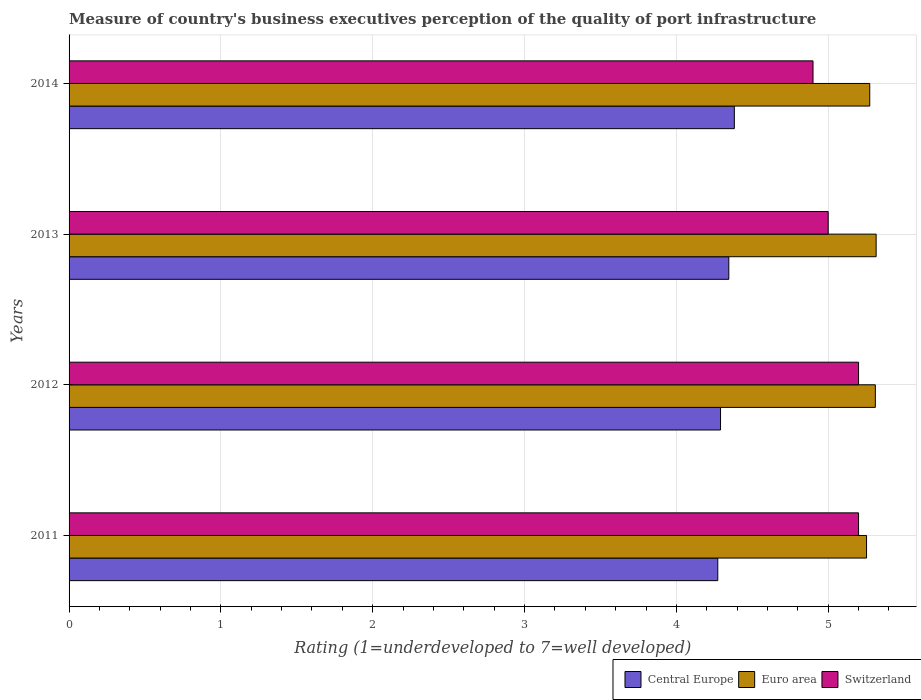Are the number of bars on each tick of the Y-axis equal?
Ensure brevity in your answer.  Yes. How many bars are there on the 4th tick from the top?
Your answer should be compact. 3. What is the label of the 3rd group of bars from the top?
Provide a succinct answer. 2012. What is the ratings of the quality of port infrastructure in Euro area in 2014?
Offer a terse response. 5.27. Across all years, what is the maximum ratings of the quality of port infrastructure in Euro area?
Ensure brevity in your answer.  5.32. In which year was the ratings of the quality of port infrastructure in Switzerland maximum?
Provide a succinct answer. 2011. In which year was the ratings of the quality of port infrastructure in Switzerland minimum?
Give a very brief answer. 2014. What is the total ratings of the quality of port infrastructure in Euro area in the graph?
Give a very brief answer. 21.15. What is the difference between the ratings of the quality of port infrastructure in Switzerland in 2012 and that in 2013?
Give a very brief answer. 0.2. What is the difference between the ratings of the quality of port infrastructure in Switzerland in 2011 and the ratings of the quality of port infrastructure in Central Europe in 2013?
Ensure brevity in your answer.  0.85. What is the average ratings of the quality of port infrastructure in Switzerland per year?
Provide a succinct answer. 5.08. In the year 2013, what is the difference between the ratings of the quality of port infrastructure in Switzerland and ratings of the quality of port infrastructure in Central Europe?
Make the answer very short. 0.65. In how many years, is the ratings of the quality of port infrastructure in Central Europe greater than 4.4 ?
Your answer should be very brief. 0. What is the ratio of the ratings of the quality of port infrastructure in Switzerland in 2011 to that in 2014?
Your answer should be compact. 1.06. Is the ratings of the quality of port infrastructure in Central Europe in 2011 less than that in 2012?
Provide a succinct answer. Yes. Is the difference between the ratings of the quality of port infrastructure in Switzerland in 2012 and 2013 greater than the difference between the ratings of the quality of port infrastructure in Central Europe in 2012 and 2013?
Keep it short and to the point. Yes. What is the difference between the highest and the second highest ratings of the quality of port infrastructure in Central Europe?
Ensure brevity in your answer.  0.04. What is the difference between the highest and the lowest ratings of the quality of port infrastructure in Switzerland?
Provide a short and direct response. 0.3. In how many years, is the ratings of the quality of port infrastructure in Central Europe greater than the average ratings of the quality of port infrastructure in Central Europe taken over all years?
Your answer should be very brief. 2. What does the 3rd bar from the top in 2012 represents?
Give a very brief answer. Central Europe. What does the 1st bar from the bottom in 2011 represents?
Your answer should be very brief. Central Europe. How many bars are there?
Make the answer very short. 12. Are all the bars in the graph horizontal?
Give a very brief answer. Yes. What is the difference between two consecutive major ticks on the X-axis?
Offer a very short reply. 1. Where does the legend appear in the graph?
Provide a succinct answer. Bottom right. How many legend labels are there?
Your response must be concise. 3. How are the legend labels stacked?
Ensure brevity in your answer.  Horizontal. What is the title of the graph?
Give a very brief answer. Measure of country's business executives perception of the quality of port infrastructure. Does "Georgia" appear as one of the legend labels in the graph?
Your answer should be compact. No. What is the label or title of the X-axis?
Ensure brevity in your answer.  Rating (1=underdeveloped to 7=well developed). What is the label or title of the Y-axis?
Make the answer very short. Years. What is the Rating (1=underdeveloped to 7=well developed) in Central Europe in 2011?
Provide a short and direct response. 4.27. What is the Rating (1=underdeveloped to 7=well developed) in Euro area in 2011?
Offer a very short reply. 5.25. What is the Rating (1=underdeveloped to 7=well developed) of Switzerland in 2011?
Give a very brief answer. 5.2. What is the Rating (1=underdeveloped to 7=well developed) of Central Europe in 2012?
Your answer should be very brief. 4.29. What is the Rating (1=underdeveloped to 7=well developed) in Euro area in 2012?
Give a very brief answer. 5.31. What is the Rating (1=underdeveloped to 7=well developed) in Central Europe in 2013?
Give a very brief answer. 4.35. What is the Rating (1=underdeveloped to 7=well developed) of Euro area in 2013?
Your answer should be very brief. 5.32. What is the Rating (1=underdeveloped to 7=well developed) in Switzerland in 2013?
Ensure brevity in your answer.  5. What is the Rating (1=underdeveloped to 7=well developed) in Central Europe in 2014?
Provide a short and direct response. 4.38. What is the Rating (1=underdeveloped to 7=well developed) of Euro area in 2014?
Provide a succinct answer. 5.27. What is the Rating (1=underdeveloped to 7=well developed) in Switzerland in 2014?
Ensure brevity in your answer.  4.9. Across all years, what is the maximum Rating (1=underdeveloped to 7=well developed) in Central Europe?
Make the answer very short. 4.38. Across all years, what is the maximum Rating (1=underdeveloped to 7=well developed) of Euro area?
Your response must be concise. 5.32. Across all years, what is the maximum Rating (1=underdeveloped to 7=well developed) in Switzerland?
Provide a short and direct response. 5.2. Across all years, what is the minimum Rating (1=underdeveloped to 7=well developed) in Central Europe?
Offer a terse response. 4.27. Across all years, what is the minimum Rating (1=underdeveloped to 7=well developed) in Euro area?
Give a very brief answer. 5.25. What is the total Rating (1=underdeveloped to 7=well developed) in Central Europe in the graph?
Offer a terse response. 17.29. What is the total Rating (1=underdeveloped to 7=well developed) in Euro area in the graph?
Ensure brevity in your answer.  21.15. What is the total Rating (1=underdeveloped to 7=well developed) in Switzerland in the graph?
Give a very brief answer. 20.3. What is the difference between the Rating (1=underdeveloped to 7=well developed) of Central Europe in 2011 and that in 2012?
Offer a very short reply. -0.02. What is the difference between the Rating (1=underdeveloped to 7=well developed) of Euro area in 2011 and that in 2012?
Offer a very short reply. -0.06. What is the difference between the Rating (1=underdeveloped to 7=well developed) in Switzerland in 2011 and that in 2012?
Provide a short and direct response. 0. What is the difference between the Rating (1=underdeveloped to 7=well developed) in Central Europe in 2011 and that in 2013?
Offer a terse response. -0.07. What is the difference between the Rating (1=underdeveloped to 7=well developed) of Euro area in 2011 and that in 2013?
Make the answer very short. -0.06. What is the difference between the Rating (1=underdeveloped to 7=well developed) of Switzerland in 2011 and that in 2013?
Your response must be concise. 0.2. What is the difference between the Rating (1=underdeveloped to 7=well developed) of Central Europe in 2011 and that in 2014?
Provide a succinct answer. -0.11. What is the difference between the Rating (1=underdeveloped to 7=well developed) of Euro area in 2011 and that in 2014?
Make the answer very short. -0.02. What is the difference between the Rating (1=underdeveloped to 7=well developed) of Central Europe in 2012 and that in 2013?
Make the answer very short. -0.05. What is the difference between the Rating (1=underdeveloped to 7=well developed) of Euro area in 2012 and that in 2013?
Provide a short and direct response. -0.01. What is the difference between the Rating (1=underdeveloped to 7=well developed) of Switzerland in 2012 and that in 2013?
Give a very brief answer. 0.2. What is the difference between the Rating (1=underdeveloped to 7=well developed) of Central Europe in 2012 and that in 2014?
Make the answer very short. -0.09. What is the difference between the Rating (1=underdeveloped to 7=well developed) in Euro area in 2012 and that in 2014?
Your response must be concise. 0.04. What is the difference between the Rating (1=underdeveloped to 7=well developed) in Switzerland in 2012 and that in 2014?
Make the answer very short. 0.3. What is the difference between the Rating (1=underdeveloped to 7=well developed) in Central Europe in 2013 and that in 2014?
Offer a terse response. -0.04. What is the difference between the Rating (1=underdeveloped to 7=well developed) in Euro area in 2013 and that in 2014?
Provide a succinct answer. 0.04. What is the difference between the Rating (1=underdeveloped to 7=well developed) of Switzerland in 2013 and that in 2014?
Keep it short and to the point. 0.1. What is the difference between the Rating (1=underdeveloped to 7=well developed) in Central Europe in 2011 and the Rating (1=underdeveloped to 7=well developed) in Euro area in 2012?
Your response must be concise. -1.04. What is the difference between the Rating (1=underdeveloped to 7=well developed) of Central Europe in 2011 and the Rating (1=underdeveloped to 7=well developed) of Switzerland in 2012?
Your response must be concise. -0.93. What is the difference between the Rating (1=underdeveloped to 7=well developed) of Euro area in 2011 and the Rating (1=underdeveloped to 7=well developed) of Switzerland in 2012?
Provide a short and direct response. 0.05. What is the difference between the Rating (1=underdeveloped to 7=well developed) of Central Europe in 2011 and the Rating (1=underdeveloped to 7=well developed) of Euro area in 2013?
Your answer should be very brief. -1.04. What is the difference between the Rating (1=underdeveloped to 7=well developed) in Central Europe in 2011 and the Rating (1=underdeveloped to 7=well developed) in Switzerland in 2013?
Your answer should be compact. -0.73. What is the difference between the Rating (1=underdeveloped to 7=well developed) of Euro area in 2011 and the Rating (1=underdeveloped to 7=well developed) of Switzerland in 2013?
Provide a short and direct response. 0.25. What is the difference between the Rating (1=underdeveloped to 7=well developed) of Central Europe in 2011 and the Rating (1=underdeveloped to 7=well developed) of Euro area in 2014?
Provide a short and direct response. -1. What is the difference between the Rating (1=underdeveloped to 7=well developed) in Central Europe in 2011 and the Rating (1=underdeveloped to 7=well developed) in Switzerland in 2014?
Keep it short and to the point. -0.63. What is the difference between the Rating (1=underdeveloped to 7=well developed) of Euro area in 2011 and the Rating (1=underdeveloped to 7=well developed) of Switzerland in 2014?
Provide a succinct answer. 0.35. What is the difference between the Rating (1=underdeveloped to 7=well developed) in Central Europe in 2012 and the Rating (1=underdeveloped to 7=well developed) in Euro area in 2013?
Keep it short and to the point. -1.02. What is the difference between the Rating (1=underdeveloped to 7=well developed) of Central Europe in 2012 and the Rating (1=underdeveloped to 7=well developed) of Switzerland in 2013?
Your response must be concise. -0.71. What is the difference between the Rating (1=underdeveloped to 7=well developed) in Euro area in 2012 and the Rating (1=underdeveloped to 7=well developed) in Switzerland in 2013?
Your answer should be compact. 0.31. What is the difference between the Rating (1=underdeveloped to 7=well developed) of Central Europe in 2012 and the Rating (1=underdeveloped to 7=well developed) of Euro area in 2014?
Your answer should be compact. -0.98. What is the difference between the Rating (1=underdeveloped to 7=well developed) in Central Europe in 2012 and the Rating (1=underdeveloped to 7=well developed) in Switzerland in 2014?
Give a very brief answer. -0.61. What is the difference between the Rating (1=underdeveloped to 7=well developed) in Euro area in 2012 and the Rating (1=underdeveloped to 7=well developed) in Switzerland in 2014?
Make the answer very short. 0.41. What is the difference between the Rating (1=underdeveloped to 7=well developed) of Central Europe in 2013 and the Rating (1=underdeveloped to 7=well developed) of Euro area in 2014?
Give a very brief answer. -0.93. What is the difference between the Rating (1=underdeveloped to 7=well developed) in Central Europe in 2013 and the Rating (1=underdeveloped to 7=well developed) in Switzerland in 2014?
Provide a short and direct response. -0.55. What is the difference between the Rating (1=underdeveloped to 7=well developed) in Euro area in 2013 and the Rating (1=underdeveloped to 7=well developed) in Switzerland in 2014?
Your response must be concise. 0.42. What is the average Rating (1=underdeveloped to 7=well developed) in Central Europe per year?
Provide a short and direct response. 4.32. What is the average Rating (1=underdeveloped to 7=well developed) in Euro area per year?
Offer a very short reply. 5.29. What is the average Rating (1=underdeveloped to 7=well developed) in Switzerland per year?
Ensure brevity in your answer.  5.08. In the year 2011, what is the difference between the Rating (1=underdeveloped to 7=well developed) of Central Europe and Rating (1=underdeveloped to 7=well developed) of Euro area?
Offer a terse response. -0.98. In the year 2011, what is the difference between the Rating (1=underdeveloped to 7=well developed) in Central Europe and Rating (1=underdeveloped to 7=well developed) in Switzerland?
Make the answer very short. -0.93. In the year 2011, what is the difference between the Rating (1=underdeveloped to 7=well developed) in Euro area and Rating (1=underdeveloped to 7=well developed) in Switzerland?
Offer a very short reply. 0.05. In the year 2012, what is the difference between the Rating (1=underdeveloped to 7=well developed) of Central Europe and Rating (1=underdeveloped to 7=well developed) of Euro area?
Provide a short and direct response. -1.02. In the year 2012, what is the difference between the Rating (1=underdeveloped to 7=well developed) of Central Europe and Rating (1=underdeveloped to 7=well developed) of Switzerland?
Make the answer very short. -0.91. In the year 2012, what is the difference between the Rating (1=underdeveloped to 7=well developed) of Euro area and Rating (1=underdeveloped to 7=well developed) of Switzerland?
Your answer should be compact. 0.11. In the year 2013, what is the difference between the Rating (1=underdeveloped to 7=well developed) of Central Europe and Rating (1=underdeveloped to 7=well developed) of Euro area?
Your answer should be compact. -0.97. In the year 2013, what is the difference between the Rating (1=underdeveloped to 7=well developed) of Central Europe and Rating (1=underdeveloped to 7=well developed) of Switzerland?
Ensure brevity in your answer.  -0.65. In the year 2013, what is the difference between the Rating (1=underdeveloped to 7=well developed) in Euro area and Rating (1=underdeveloped to 7=well developed) in Switzerland?
Your answer should be very brief. 0.32. In the year 2014, what is the difference between the Rating (1=underdeveloped to 7=well developed) in Central Europe and Rating (1=underdeveloped to 7=well developed) in Euro area?
Make the answer very short. -0.89. In the year 2014, what is the difference between the Rating (1=underdeveloped to 7=well developed) in Central Europe and Rating (1=underdeveloped to 7=well developed) in Switzerland?
Give a very brief answer. -0.52. In the year 2014, what is the difference between the Rating (1=underdeveloped to 7=well developed) in Euro area and Rating (1=underdeveloped to 7=well developed) in Switzerland?
Make the answer very short. 0.37. What is the ratio of the Rating (1=underdeveloped to 7=well developed) in Central Europe in 2011 to that in 2012?
Provide a short and direct response. 1. What is the ratio of the Rating (1=underdeveloped to 7=well developed) in Euro area in 2011 to that in 2012?
Make the answer very short. 0.99. What is the ratio of the Rating (1=underdeveloped to 7=well developed) of Central Europe in 2011 to that in 2013?
Make the answer very short. 0.98. What is the ratio of the Rating (1=underdeveloped to 7=well developed) of Euro area in 2011 to that in 2013?
Offer a terse response. 0.99. What is the ratio of the Rating (1=underdeveloped to 7=well developed) in Switzerland in 2011 to that in 2013?
Provide a succinct answer. 1.04. What is the ratio of the Rating (1=underdeveloped to 7=well developed) of Central Europe in 2011 to that in 2014?
Make the answer very short. 0.98. What is the ratio of the Rating (1=underdeveloped to 7=well developed) in Switzerland in 2011 to that in 2014?
Your answer should be very brief. 1.06. What is the ratio of the Rating (1=underdeveloped to 7=well developed) in Central Europe in 2012 to that in 2013?
Provide a succinct answer. 0.99. What is the ratio of the Rating (1=underdeveloped to 7=well developed) of Euro area in 2012 to that in 2013?
Make the answer very short. 1. What is the ratio of the Rating (1=underdeveloped to 7=well developed) in Switzerland in 2012 to that in 2013?
Keep it short and to the point. 1.04. What is the ratio of the Rating (1=underdeveloped to 7=well developed) in Central Europe in 2012 to that in 2014?
Provide a succinct answer. 0.98. What is the ratio of the Rating (1=underdeveloped to 7=well developed) of Euro area in 2012 to that in 2014?
Your answer should be very brief. 1.01. What is the ratio of the Rating (1=underdeveloped to 7=well developed) in Switzerland in 2012 to that in 2014?
Offer a terse response. 1.06. What is the ratio of the Rating (1=underdeveloped to 7=well developed) in Switzerland in 2013 to that in 2014?
Your response must be concise. 1.02. What is the difference between the highest and the second highest Rating (1=underdeveloped to 7=well developed) in Central Europe?
Offer a very short reply. 0.04. What is the difference between the highest and the second highest Rating (1=underdeveloped to 7=well developed) in Euro area?
Provide a succinct answer. 0.01. What is the difference between the highest and the second highest Rating (1=underdeveloped to 7=well developed) of Switzerland?
Your response must be concise. 0. What is the difference between the highest and the lowest Rating (1=underdeveloped to 7=well developed) in Central Europe?
Your answer should be very brief. 0.11. What is the difference between the highest and the lowest Rating (1=underdeveloped to 7=well developed) of Euro area?
Keep it short and to the point. 0.06. 